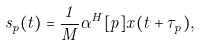Convert formula to latex. <formula><loc_0><loc_0><loc_500><loc_500>\widehat { s } _ { p } ( t ) = \frac { 1 } { M } \alpha ^ { H } [ p ] x ( t + \tau _ { p } ) ,</formula> 